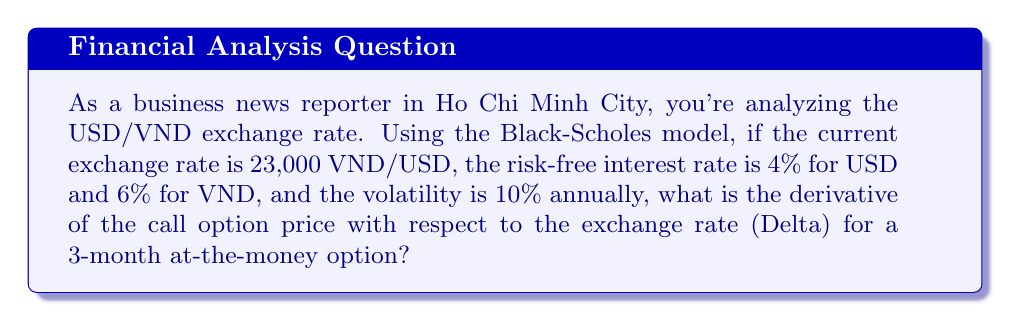Solve this math problem. To solve this problem, we'll use the Black-Scholes formula for the Delta of a currency option:

1) The Delta for a call option is given by:
   $$\Delta_{\text{call}} = e^{-r_f T} N(d_1)$$

   Where:
   $r_f$ is the foreign risk-free rate (USD in this case)
   $T$ is the time to expiration in years
   $N(d_1)$ is the cumulative normal distribution of $d_1$

2) Calculate $d_1$:
   $$d_1 = \frac{\ln(S/K) + (r_d - r_f + \sigma^2/2)T}{\sigma\sqrt{T}}$$

   Where:
   $S$ is the current exchange rate (23,000 VND/USD)
   $K$ is the strike price (same as $S$ for at-the-money option)
   $r_d$ is the domestic risk-free rate (VND)
   $\sigma$ is the volatility

3) Let's plug in the values:
   $S = K = 23,000$, $r_d = 6\% = 0.06$, $r_f = 4\% = 0.04$, $\sigma = 10\% = 0.1$, $T = 3/12 = 0.25$

4) Calculate $d_1$:
   $$d_1 = \frac{\ln(1) + (0.06 - 0.04 + 0.1^2/2) * 0.25}{0.1\sqrt{0.25}} = 0.1581$$

5) Calculate $N(d_1)$:
   $N(0.1581) \approx 0.5628$ (using a standard normal distribution table or calculator)

6) Finally, calculate Delta:
   $$\Delta_{\text{call}} = e^{-0.04 * 0.25} * 0.5628 \approx 0.5594$$
Answer: 0.5594 